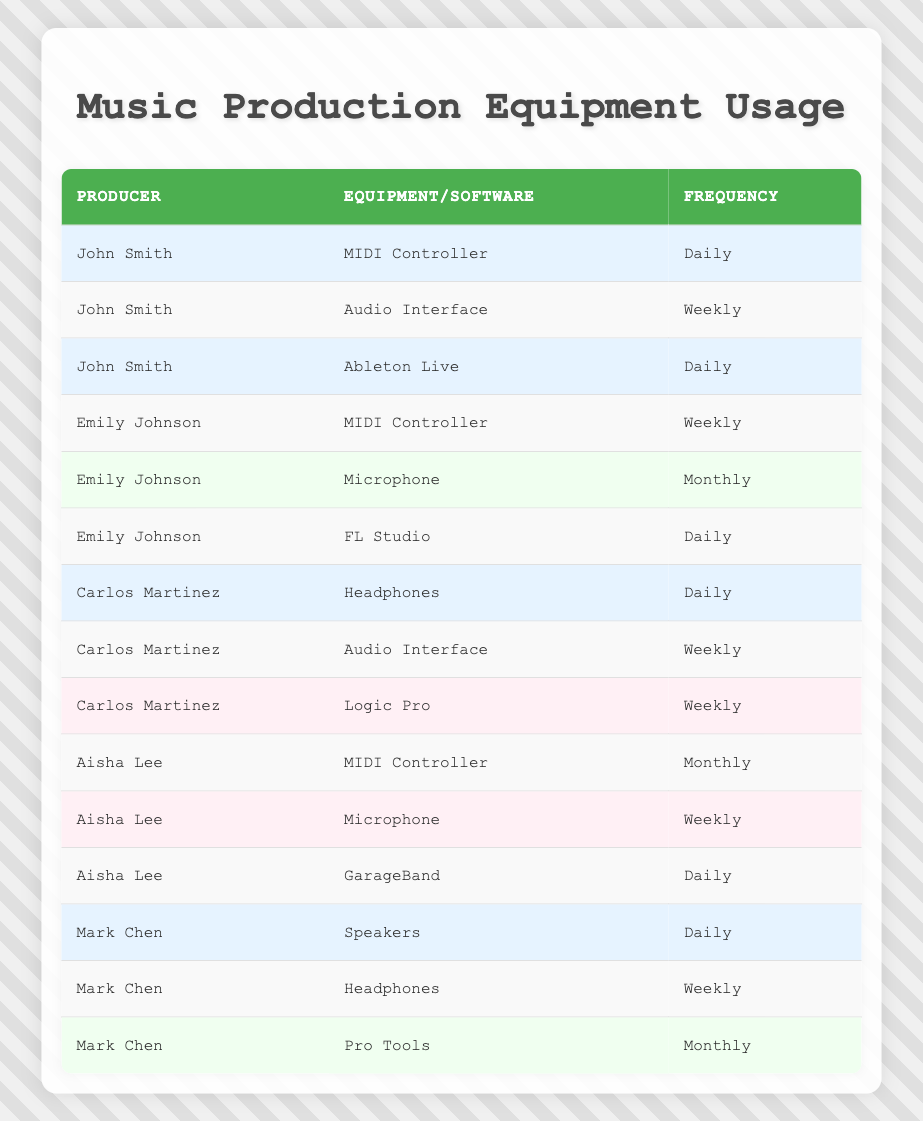What type of software does Carlos Martinez use? Referring to the table, under Carlos Martinez's row, he has two entries, one for Audio Interface and one for Logic Pro, where the software is mentioned as Logic Pro.
Answer: Logic Pro How many producers use a MIDI Controller daily? The table shows that only John Smith uses a MIDI Controller daily in one entry. Hence, there’s one producer noted for that frequency.
Answer: 1 Which piece of equipment is used most frequently by Aisha Lee? The table indicates Aisha Lee uses GarageBand daily, which is more frequent than her other equipment, the MIDI Controller and Microphone, which are used monthly and weekly, respectively.
Answer: GarageBand Is Mark Chen's usage of Pro Tools weekly? In the table, Mark Chen's entry for Pro Tools shows a frequency of monthly, therefore his usage is not weekly.
Answer: No What is the average frequency of equipment usage among the listed producers? First, we classify the frequencies: Daily (5 instances), Weekly (6 instances), and Monthly (4 instances). Total counts are 15 instances (5 + 6 + 4). Average: (5 * 1 + 6 * 2 + 4 * 3)/15 = (5 + 12 + 12)/15 = 29/15 = 1.93, or approximately 2 when considering frequency levels.
Answer: Approximately 2 Which producer uses both a MIDI Controller and an Audio Interface? Looking at the data, John Smith has both a MIDI Controller (daily) and an Audio Interface (weekly). There are no other producers with both.
Answer: John Smith How many different pieces of equipment does Emily Johnson use? Emily Johnson has two separate pieces of equipment listed: MIDI Controller and Microphone. Counting those entries, Emily uses two different pieces of equipment.
Answer: 2 Which producer has the most frequent equipment usage? By examining the table, John Smith uses a MIDI Controller and Ableton Live both daily, making his usage the most frequent.
Answer: John Smith Does any producer use a microphone daily? In the table, we can see that Aisha Lee uses a microphone weekly, while Emily Johnson uses hers monthly. Therefore, no producer uses a microphone daily.
Answer: No 